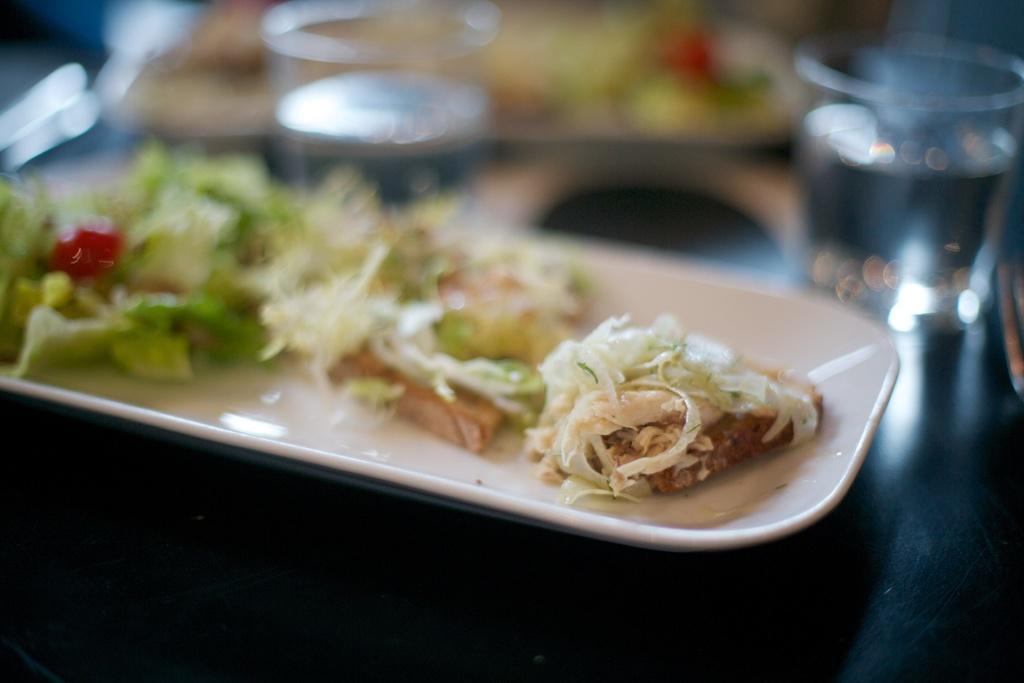What is the main object in the center of the image? There is a table in the center of the image. What items are placed on the table? There are plates, glasses, and food items on the table. What type of hair can be seen on the food items in the image? There is no hair visible on the food items in the image. What joke is being told by the food items in the image? There is no joke being told by the food items in the image. 